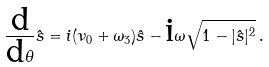<formula> <loc_0><loc_0><loc_500><loc_500>\frac { \text {d} } { \text {d} \theta } \hat { s } = i ( \nu _ { 0 } + \omega _ { 3 } ) \hat { s } - \text {i} \omega \sqrt { 1 - | \hat { s } | ^ { 2 } } \, .</formula> 